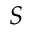Convert formula to latex. <formula><loc_0><loc_0><loc_500><loc_500>S</formula> 